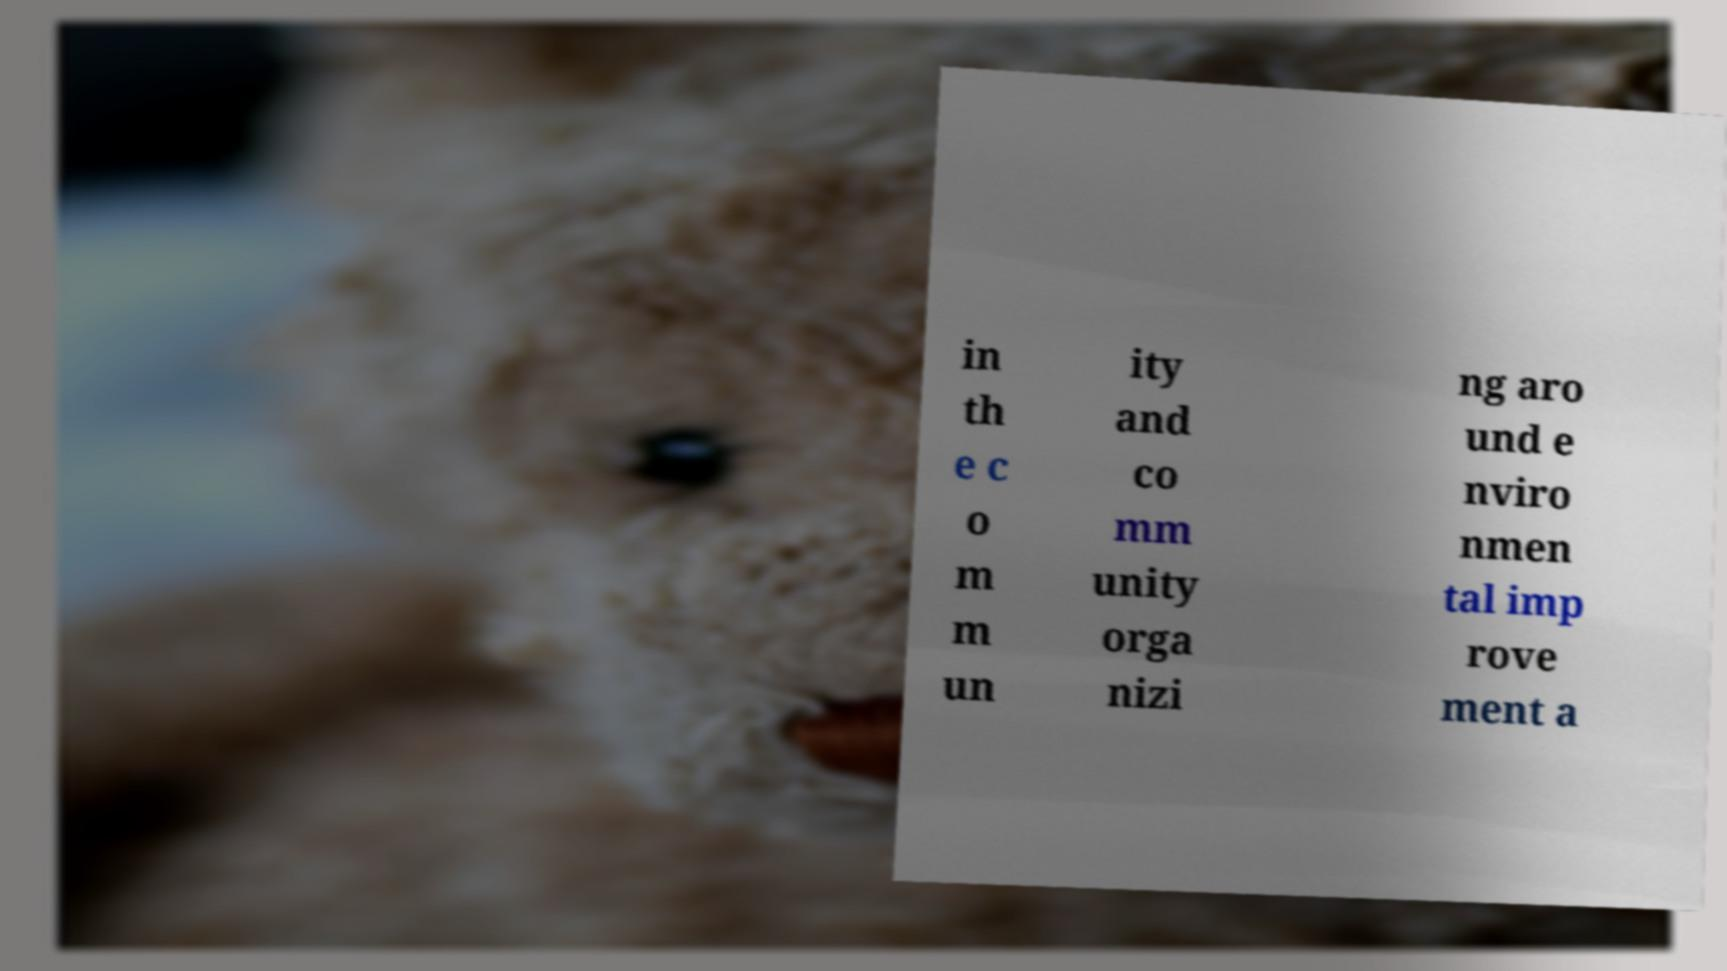Could you extract and type out the text from this image? in th e c o m m un ity and co mm unity orga nizi ng aro und e nviro nmen tal imp rove ment a 